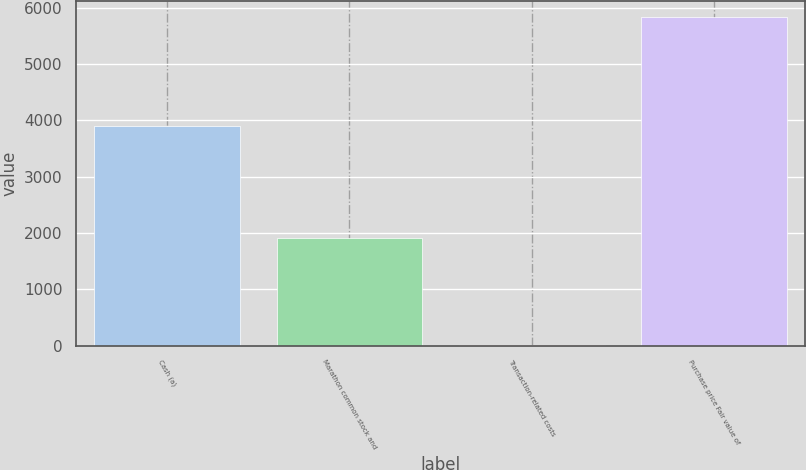Convert chart. <chart><loc_0><loc_0><loc_500><loc_500><bar_chart><fcel>Cash (a)<fcel>Marathon common stock and<fcel>Transaction-related costs<fcel>Purchase price Fair value of<nl><fcel>3907<fcel>1910<fcel>16<fcel>5833<nl></chart> 